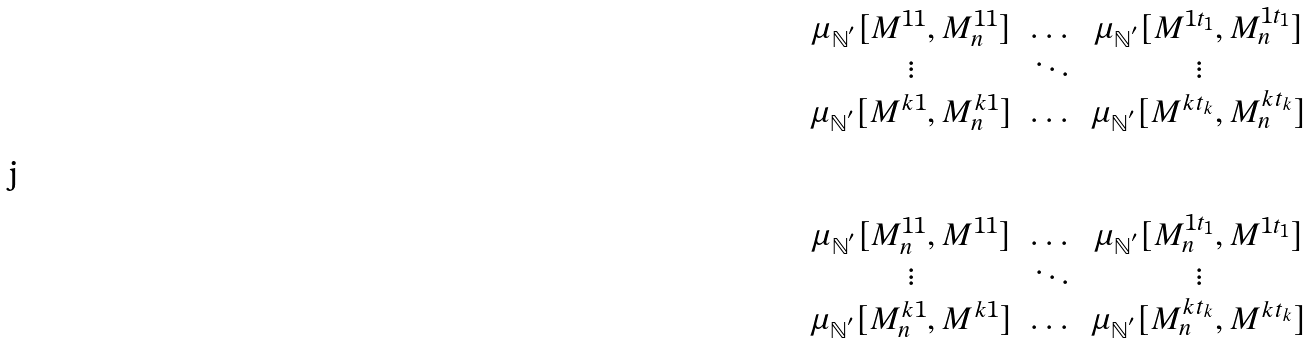<formula> <loc_0><loc_0><loc_500><loc_500>\begin{matrix} \mu _ { \mathbb { N } ^ { ^ { \prime } } } [ M ^ { 1 1 } , M ^ { 1 1 } _ { n } ] & \dots & \mu _ { \mathbb { N } ^ { ^ { \prime } } } [ M ^ { 1 t _ { 1 } } , M ^ { 1 t _ { 1 } } _ { n } ] \\ \vdots & \ddots & \vdots \\ \mu _ { \mathbb { N } ^ { ^ { \prime } } } [ M ^ { k 1 } , M ^ { k 1 } _ { n } ] & \dots & \mu _ { \mathbb { N } ^ { ^ { \prime } } } [ M ^ { k t _ { k } } , M ^ { k t _ { k } } _ { n } ] \\ \\ \\ \mu _ { \mathbb { N } ^ { ^ { \prime } } } [ M ^ { 1 1 } _ { n } , M ^ { 1 1 } ] & \dots & \mu _ { \mathbb { N } ^ { ^ { \prime } } } [ M ^ { 1 t _ { 1 } } _ { n } , M ^ { 1 t _ { 1 } } ] \\ \vdots & \ddots & \vdots \\ \mu _ { \mathbb { N } ^ { ^ { \prime } } } [ M ^ { k 1 } _ { n } , M ^ { k 1 } ] & \dots & \mu _ { \mathbb { N } ^ { ^ { \prime } } } [ M ^ { k t _ { k } } _ { n } , M ^ { k t _ { k } } ] \end{matrix}</formula> 